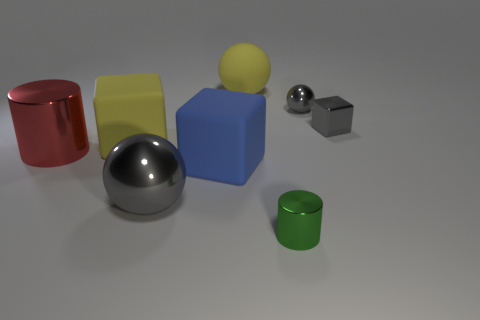Add 1 tiny green metallic objects. How many objects exist? 9 Subtract all red cylinders. How many cylinders are left? 1 Subtract all small gray metal cubes. How many cubes are left? 2 Subtract all blocks. How many objects are left? 5 Subtract 1 blocks. How many blocks are left? 2 Subtract all purple cubes. Subtract all red balls. How many cubes are left? 3 Subtract all brown spheres. How many green cylinders are left? 1 Add 8 big yellow matte spheres. How many big yellow matte spheres are left? 9 Add 6 small shiny blocks. How many small shiny blocks exist? 7 Subtract 0 purple cylinders. How many objects are left? 8 